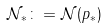<formula> <loc_0><loc_0><loc_500><loc_500>\mathcal { N } _ { \ast } \colon = \mathcal { N } ( p _ { \ast } )</formula> 